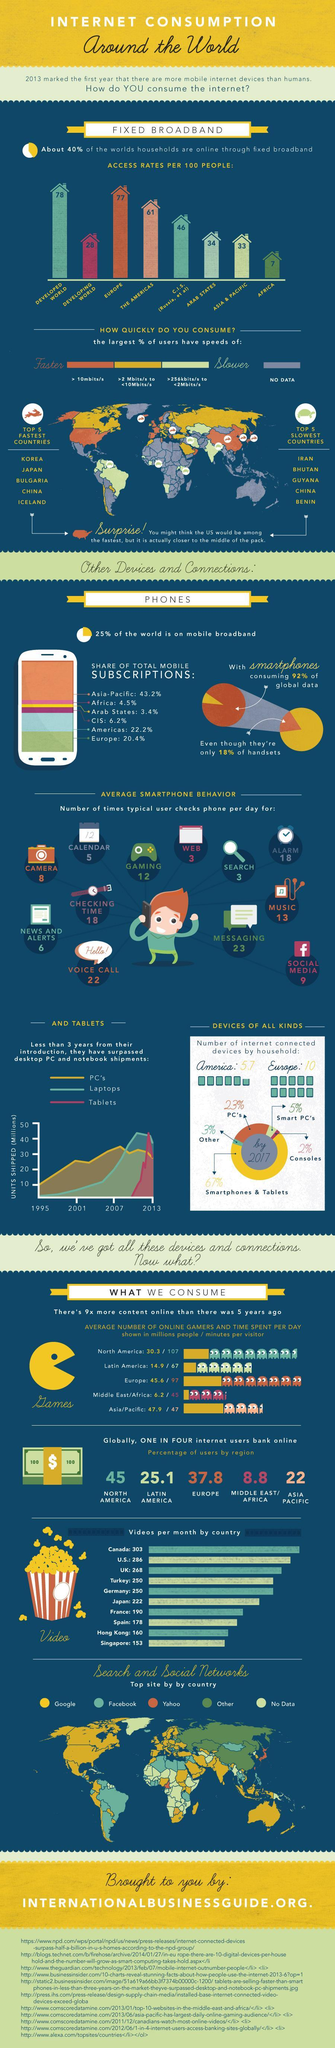What is the total mobile subscriptions in Africa and CIS, taken together?
Answer the question with a short phrase. 10.7% What percentage of global data is not consumed by smartphones? 8% What is the percentage of internet users bank online in the Asia Pacific region? 22 What is the number of times a typical user checks phone per day for gaming? 12 What is the number of internet-connected devices by households in America and Europe, taken together? 15.7 What percentage of the world is not on mobile broadband? 75% What is the number of times a typical user checks phone per day for alarm? 18 What is the percentage of internet users bank online in Europe? 37.8 What is the total mobile subscriptions in the Americas and Europe, taken together? 42.6% What is the number of times a typical user checks phone per day for music? 13 